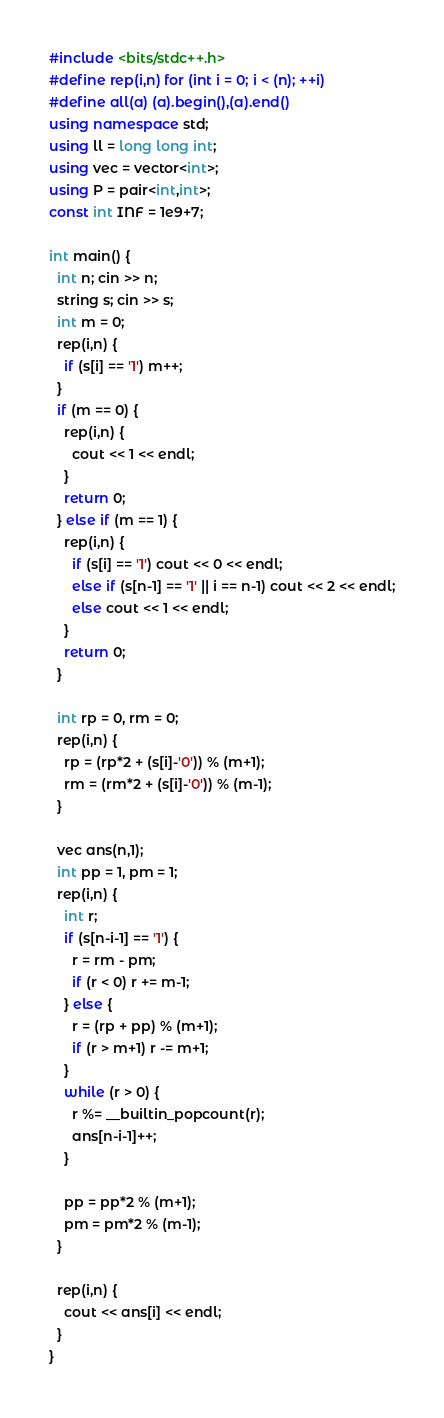Convert code to text. <code><loc_0><loc_0><loc_500><loc_500><_C++_>#include <bits/stdc++.h>
#define rep(i,n) for (int i = 0; i < (n); ++i)
#define all(a) (a).begin(),(a).end()
using namespace std;
using ll = long long int;
using vec = vector<int>;
using P = pair<int,int>;
const int INF = 1e9+7;

int main() {
  int n; cin >> n;
  string s; cin >> s;
  int m = 0;
  rep(i,n) {
    if (s[i] == '1') m++;
  }
  if (m == 0) {
    rep(i,n) {
      cout << 1 << endl;
    }
    return 0;
  } else if (m == 1) {
    rep(i,n) {
      if (s[i] == '1') cout << 0 << endl;
      else if (s[n-1] == '1' || i == n-1) cout << 2 << endl;
      else cout << 1 << endl;
    }
    return 0;
  }

  int rp = 0, rm = 0;
  rep(i,n) {
    rp = (rp*2 + (s[i]-'0')) % (m+1);
    rm = (rm*2 + (s[i]-'0')) % (m-1);
  }

  vec ans(n,1);
  int pp = 1, pm = 1;
  rep(i,n) {
    int r;
    if (s[n-i-1] == '1') {
      r = rm - pm;
      if (r < 0) r += m-1;
    } else {
      r = (rp + pp) % (m+1);
      if (r > m+1) r -= m+1;
    }
    while (r > 0) {
      r %= __builtin_popcount(r);
      ans[n-i-1]++;
    }

    pp = pp*2 % (m+1);
    pm = pm*2 % (m-1);
  }

  rep(i,n) {
    cout << ans[i] << endl;
  }
}
</code> 